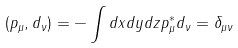Convert formula to latex. <formula><loc_0><loc_0><loc_500><loc_500>( p _ { \mu } , d _ { \nu } ) = - \int d x d y d z p _ { \mu } ^ { \ast } d _ { \nu } = \delta _ { \mu \nu }</formula> 